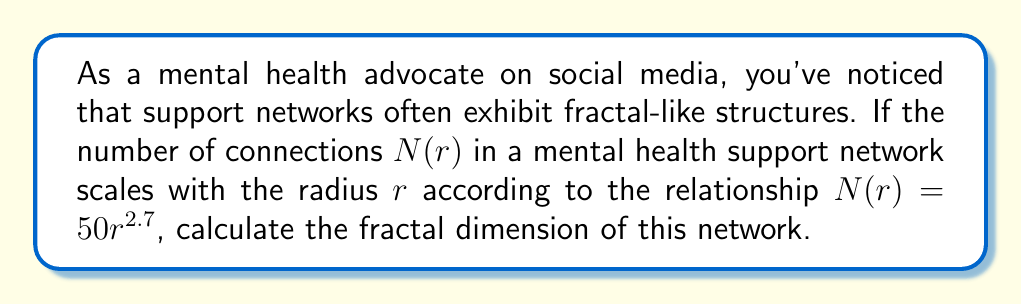Provide a solution to this math problem. To calculate the fractal dimension of the mental health support network, we'll follow these steps:

1) The fractal dimension $D$ is defined by the relationship:

   $$N(r) \propto r^D$$

   where $N(r)$ is the number of objects (in this case, connections) within a radius $r$.

2) In our case, we're given:

   $$N(r) = 50r^{2.7}$$

3) Comparing this to the general form, we can see that the exponent of $r$ is the fractal dimension. Therefore:

   $$D = 2.7$$

4) This non-integer dimension indicates that the mental health support network has a fractal structure. It's more complex than a simple 2D network (which would have $D=2$) but less space-filling than a 3D network ($D=3$).

5) In the context of mental health advocacy, this fractal dimension suggests that support networks have a complex, self-similar structure across different scales. As you expand your reach as an influencer, you may find that the network of connections grows in a non-linear way, with clusters of support forming at various levels.
Answer: $D = 2.7$ 